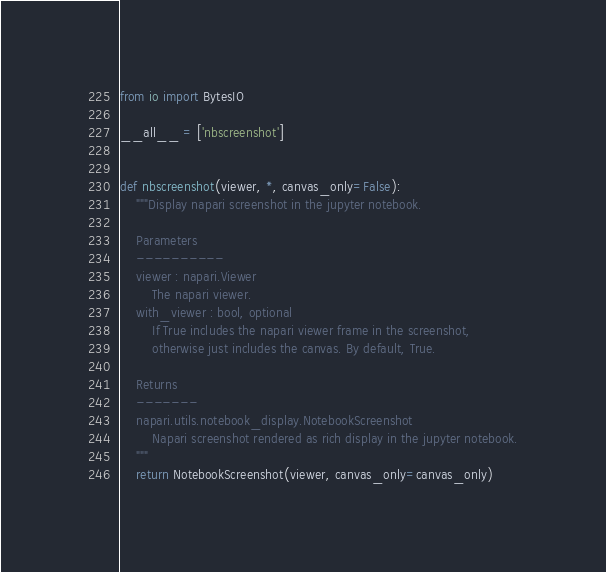<code> <loc_0><loc_0><loc_500><loc_500><_Python_>from io import BytesIO

__all__ = ['nbscreenshot']


def nbscreenshot(viewer, *, canvas_only=False):
    """Display napari screenshot in the jupyter notebook.

    Parameters
    ----------
    viewer : napari.Viewer
        The napari viewer.
    with_viewer : bool, optional
        If True includes the napari viewer frame in the screenshot,
        otherwise just includes the canvas. By default, True.

    Returns
    -------
    napari.utils.notebook_display.NotebookScreenshot
        Napari screenshot rendered as rich display in the jupyter notebook.
    """
    return NotebookScreenshot(viewer, canvas_only=canvas_only)

</code> 